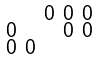<formula> <loc_0><loc_0><loc_500><loc_500>\begin{smallmatrix} & & 0 & 0 & 0 \\ 0 & & & 0 & 0 \\ 0 & 0 & & & \end{smallmatrix}</formula> 